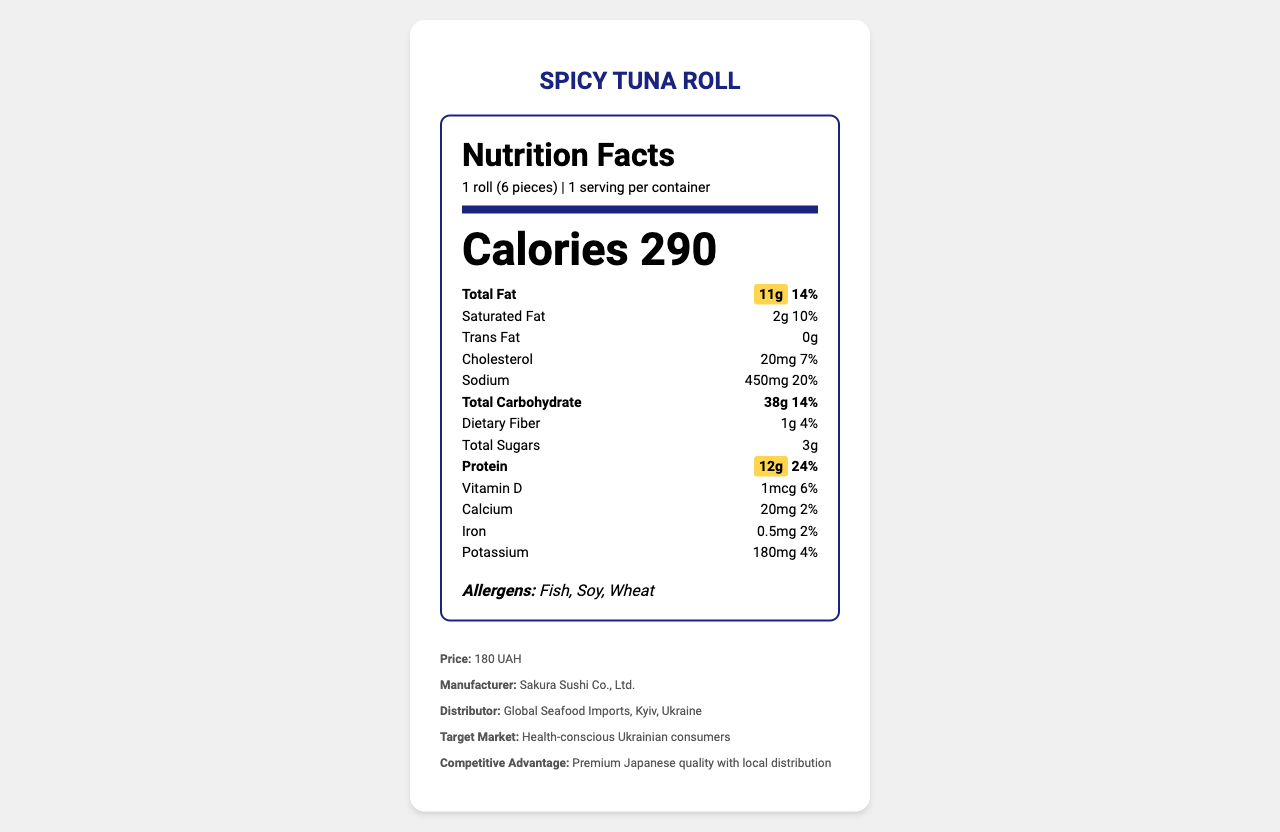what is the serving size? The serving size is clearly stated as "1 roll (6 pieces)."
Answer: 1 roll (6 pieces) how many grams of protein does one serving contain? The document specifies that the protein content per serving is 12g.
Answer: 12g what is the daily value percentage of total fat? The total fat content has a daily value percentage of 14%.
Answer: 14% name three allergens in this product The allergens listed in the document are Fish, Soy, and Wheat.
Answer: Fish, Soy, Wheat what is the manufacturer of the Spicy Tuna Roll? The manufacturer is mentioned as "Sakura Sushi Co., Ltd."
Answer: Sakura Sushi Co., Ltd. which nutrient has the highest daily value percentage? A. Vitamin D B. Sodium C. Protein D. Calcium Sodium has a daily value percentage of 20%, which is the highest among the listed nutrients.
Answer: B how much does one roll cost? A. 150 UAH B. 180 UAH C. 200 UAH D. 220 UAH The price of one roll is stated as 180 UAH.
Answer: B is the total carbohydrate content less than 50g per serving? (Yes/No) The total carbohydrate content is stated as 38g, which is less than 50g per serving.
Answer: Yes name one sustainability information mentioned in the document The sustainability information provided is "Tuna sourced from MSC certified fisheries."
Answer: Tuna sourced from MSC certified fisheries what is the net weight of the Spicy Tuna Roll? The net weight is specified as 120g.
Answer: 120g what is the target market for this product? The target market is identified as "Health-conscious Ukrainian consumers."
Answer: Health-conscious Ukrainian consumers what information is provided under the business context section? The business context section includes details about the target market, competitive advantage, and potential partnership benefits.
Answer: Target market, Competitive advantage, Potential partnership benefits does the document state the preparation method of the sushi? True/False The preparation method is described as "Hand-rolled."
Answer: True summarize the main idea of the document The document offers comprehensive information about the Spicy Tuna Roll, highlighting its nutritional content, allergens, ingredients, and additional business-related details.
Answer: The document provides detailed nutritional information for Spicy Tuna Roll, including protein and fat content, along with other relevant details such as allergens, ingredients, preparation method, storage instructions, manufacturer information, and business context. what is the tuna sourcing information? The document only specifies that the tuna is sourced from MSC certified fisheries without further details.
Answer: Not enough information 